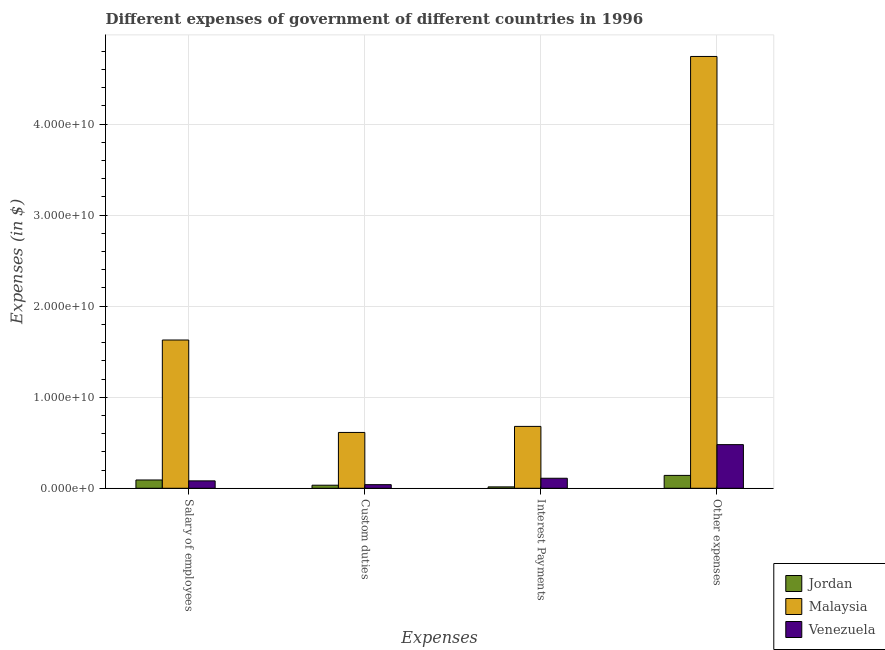How many groups of bars are there?
Offer a very short reply. 4. Are the number of bars on each tick of the X-axis equal?
Your answer should be very brief. Yes. How many bars are there on the 1st tick from the left?
Keep it short and to the point. 3. What is the label of the 3rd group of bars from the left?
Ensure brevity in your answer.  Interest Payments. What is the amount spent on interest payments in Malaysia?
Your answer should be very brief. 6.80e+09. Across all countries, what is the maximum amount spent on interest payments?
Your answer should be very brief. 6.80e+09. Across all countries, what is the minimum amount spent on other expenses?
Provide a succinct answer. 1.41e+09. In which country was the amount spent on interest payments maximum?
Provide a succinct answer. Malaysia. In which country was the amount spent on other expenses minimum?
Your answer should be compact. Jordan. What is the total amount spent on salary of employees in the graph?
Offer a very short reply. 1.80e+1. What is the difference between the amount spent on custom duties in Malaysia and that in Venezuela?
Ensure brevity in your answer.  5.73e+09. What is the difference between the amount spent on salary of employees in Malaysia and the amount spent on other expenses in Jordan?
Make the answer very short. 1.49e+1. What is the average amount spent on salary of employees per country?
Offer a very short reply. 6.00e+09. What is the difference between the amount spent on interest payments and amount spent on custom duties in Venezuela?
Give a very brief answer. 7.02e+08. What is the ratio of the amount spent on custom duties in Malaysia to that in Venezuela?
Make the answer very short. 15.41. Is the amount spent on interest payments in Malaysia less than that in Jordan?
Offer a very short reply. No. Is the difference between the amount spent on salary of employees in Jordan and Malaysia greater than the difference between the amount spent on other expenses in Jordan and Malaysia?
Provide a short and direct response. Yes. What is the difference between the highest and the second highest amount spent on salary of employees?
Keep it short and to the point. 1.54e+1. What is the difference between the highest and the lowest amount spent on interest payments?
Your response must be concise. 6.64e+09. Is the sum of the amount spent on salary of employees in Jordan and Venezuela greater than the maximum amount spent on interest payments across all countries?
Your response must be concise. No. What does the 1st bar from the left in Interest Payments represents?
Provide a short and direct response. Jordan. What does the 2nd bar from the right in Custom duties represents?
Offer a terse response. Malaysia. How many countries are there in the graph?
Give a very brief answer. 3. What is the difference between two consecutive major ticks on the Y-axis?
Provide a succinct answer. 1.00e+1. Are the values on the major ticks of Y-axis written in scientific E-notation?
Offer a very short reply. Yes. Where does the legend appear in the graph?
Offer a very short reply. Bottom right. How many legend labels are there?
Make the answer very short. 3. How are the legend labels stacked?
Provide a short and direct response. Vertical. What is the title of the graph?
Your answer should be compact. Different expenses of government of different countries in 1996. What is the label or title of the X-axis?
Provide a short and direct response. Expenses. What is the label or title of the Y-axis?
Your answer should be very brief. Expenses (in $). What is the Expenses (in $) of Jordan in Salary of employees?
Provide a succinct answer. 9.11e+08. What is the Expenses (in $) in Malaysia in Salary of employees?
Your answer should be very brief. 1.63e+1. What is the Expenses (in $) in Venezuela in Salary of employees?
Offer a very short reply. 8.14e+08. What is the Expenses (in $) in Jordan in Custom duties?
Make the answer very short. 3.36e+08. What is the Expenses (in $) in Malaysia in Custom duties?
Keep it short and to the point. 6.13e+09. What is the Expenses (in $) in Venezuela in Custom duties?
Provide a short and direct response. 3.98e+08. What is the Expenses (in $) of Jordan in Interest Payments?
Provide a short and direct response. 1.53e+08. What is the Expenses (in $) of Malaysia in Interest Payments?
Offer a terse response. 6.80e+09. What is the Expenses (in $) in Venezuela in Interest Payments?
Give a very brief answer. 1.10e+09. What is the Expenses (in $) of Jordan in Other expenses?
Provide a short and direct response. 1.41e+09. What is the Expenses (in $) of Malaysia in Other expenses?
Ensure brevity in your answer.  4.74e+1. What is the Expenses (in $) in Venezuela in Other expenses?
Give a very brief answer. 4.79e+09. Across all Expenses, what is the maximum Expenses (in $) in Jordan?
Provide a succinct answer. 1.41e+09. Across all Expenses, what is the maximum Expenses (in $) in Malaysia?
Make the answer very short. 4.74e+1. Across all Expenses, what is the maximum Expenses (in $) in Venezuela?
Make the answer very short. 4.79e+09. Across all Expenses, what is the minimum Expenses (in $) of Jordan?
Your answer should be compact. 1.53e+08. Across all Expenses, what is the minimum Expenses (in $) of Malaysia?
Give a very brief answer. 6.13e+09. Across all Expenses, what is the minimum Expenses (in $) of Venezuela?
Your response must be concise. 3.98e+08. What is the total Expenses (in $) in Jordan in the graph?
Offer a very short reply. 2.82e+09. What is the total Expenses (in $) of Malaysia in the graph?
Ensure brevity in your answer.  7.66e+1. What is the total Expenses (in $) in Venezuela in the graph?
Your answer should be compact. 7.10e+09. What is the difference between the Expenses (in $) in Jordan in Salary of employees and that in Custom duties?
Your answer should be very brief. 5.75e+08. What is the difference between the Expenses (in $) of Malaysia in Salary of employees and that in Custom duties?
Offer a very short reply. 1.02e+1. What is the difference between the Expenses (in $) in Venezuela in Salary of employees and that in Custom duties?
Give a very brief answer. 4.16e+08. What is the difference between the Expenses (in $) in Jordan in Salary of employees and that in Interest Payments?
Provide a succinct answer. 7.58e+08. What is the difference between the Expenses (in $) in Malaysia in Salary of employees and that in Interest Payments?
Your answer should be very brief. 9.49e+09. What is the difference between the Expenses (in $) in Venezuela in Salary of employees and that in Interest Payments?
Your answer should be compact. -2.86e+08. What is the difference between the Expenses (in $) of Jordan in Salary of employees and that in Other expenses?
Offer a very short reply. -5.04e+08. What is the difference between the Expenses (in $) in Malaysia in Salary of employees and that in Other expenses?
Provide a succinct answer. -3.11e+1. What is the difference between the Expenses (in $) of Venezuela in Salary of employees and that in Other expenses?
Give a very brief answer. -3.98e+09. What is the difference between the Expenses (in $) of Jordan in Custom duties and that in Interest Payments?
Ensure brevity in your answer.  1.83e+08. What is the difference between the Expenses (in $) of Malaysia in Custom duties and that in Interest Payments?
Make the answer very short. -6.63e+08. What is the difference between the Expenses (in $) of Venezuela in Custom duties and that in Interest Payments?
Make the answer very short. -7.02e+08. What is the difference between the Expenses (in $) in Jordan in Custom duties and that in Other expenses?
Your response must be concise. -1.08e+09. What is the difference between the Expenses (in $) in Malaysia in Custom duties and that in Other expenses?
Ensure brevity in your answer.  -4.13e+1. What is the difference between the Expenses (in $) in Venezuela in Custom duties and that in Other expenses?
Make the answer very short. -4.39e+09. What is the difference between the Expenses (in $) in Jordan in Interest Payments and that in Other expenses?
Provide a succinct answer. -1.26e+09. What is the difference between the Expenses (in $) of Malaysia in Interest Payments and that in Other expenses?
Provide a short and direct response. -4.06e+1. What is the difference between the Expenses (in $) in Venezuela in Interest Payments and that in Other expenses?
Your answer should be very brief. -3.69e+09. What is the difference between the Expenses (in $) in Jordan in Salary of employees and the Expenses (in $) in Malaysia in Custom duties?
Offer a terse response. -5.22e+09. What is the difference between the Expenses (in $) in Jordan in Salary of employees and the Expenses (in $) in Venezuela in Custom duties?
Offer a very short reply. 5.13e+08. What is the difference between the Expenses (in $) in Malaysia in Salary of employees and the Expenses (in $) in Venezuela in Custom duties?
Make the answer very short. 1.59e+1. What is the difference between the Expenses (in $) in Jordan in Salary of employees and the Expenses (in $) in Malaysia in Interest Payments?
Keep it short and to the point. -5.88e+09. What is the difference between the Expenses (in $) in Jordan in Salary of employees and the Expenses (in $) in Venezuela in Interest Payments?
Ensure brevity in your answer.  -1.89e+08. What is the difference between the Expenses (in $) in Malaysia in Salary of employees and the Expenses (in $) in Venezuela in Interest Payments?
Your response must be concise. 1.52e+1. What is the difference between the Expenses (in $) of Jordan in Salary of employees and the Expenses (in $) of Malaysia in Other expenses?
Make the answer very short. -4.65e+1. What is the difference between the Expenses (in $) in Jordan in Salary of employees and the Expenses (in $) in Venezuela in Other expenses?
Provide a succinct answer. -3.88e+09. What is the difference between the Expenses (in $) of Malaysia in Salary of employees and the Expenses (in $) of Venezuela in Other expenses?
Offer a very short reply. 1.15e+1. What is the difference between the Expenses (in $) of Jordan in Custom duties and the Expenses (in $) of Malaysia in Interest Payments?
Keep it short and to the point. -6.46e+09. What is the difference between the Expenses (in $) in Jordan in Custom duties and the Expenses (in $) in Venezuela in Interest Payments?
Make the answer very short. -7.64e+08. What is the difference between the Expenses (in $) of Malaysia in Custom duties and the Expenses (in $) of Venezuela in Interest Payments?
Your answer should be very brief. 5.03e+09. What is the difference between the Expenses (in $) in Jordan in Custom duties and the Expenses (in $) in Malaysia in Other expenses?
Make the answer very short. -4.71e+1. What is the difference between the Expenses (in $) of Jordan in Custom duties and the Expenses (in $) of Venezuela in Other expenses?
Offer a very short reply. -4.46e+09. What is the difference between the Expenses (in $) in Malaysia in Custom duties and the Expenses (in $) in Venezuela in Other expenses?
Give a very brief answer. 1.34e+09. What is the difference between the Expenses (in $) in Jordan in Interest Payments and the Expenses (in $) in Malaysia in Other expenses?
Offer a terse response. -4.73e+1. What is the difference between the Expenses (in $) of Jordan in Interest Payments and the Expenses (in $) of Venezuela in Other expenses?
Your answer should be compact. -4.64e+09. What is the difference between the Expenses (in $) in Malaysia in Interest Payments and the Expenses (in $) in Venezuela in Other expenses?
Keep it short and to the point. 2.00e+09. What is the average Expenses (in $) of Jordan per Expenses?
Your answer should be compact. 7.04e+08. What is the average Expenses (in $) of Malaysia per Expenses?
Keep it short and to the point. 1.92e+1. What is the average Expenses (in $) of Venezuela per Expenses?
Provide a short and direct response. 1.78e+09. What is the difference between the Expenses (in $) in Jordan and Expenses (in $) in Malaysia in Salary of employees?
Offer a terse response. -1.54e+1. What is the difference between the Expenses (in $) in Jordan and Expenses (in $) in Venezuela in Salary of employees?
Your answer should be compact. 9.70e+07. What is the difference between the Expenses (in $) in Malaysia and Expenses (in $) in Venezuela in Salary of employees?
Give a very brief answer. 1.55e+1. What is the difference between the Expenses (in $) of Jordan and Expenses (in $) of Malaysia in Custom duties?
Your answer should be compact. -5.80e+09. What is the difference between the Expenses (in $) of Jordan and Expenses (in $) of Venezuela in Custom duties?
Make the answer very short. -6.17e+07. What is the difference between the Expenses (in $) of Malaysia and Expenses (in $) of Venezuela in Custom duties?
Your answer should be very brief. 5.73e+09. What is the difference between the Expenses (in $) of Jordan and Expenses (in $) of Malaysia in Interest Payments?
Provide a succinct answer. -6.64e+09. What is the difference between the Expenses (in $) in Jordan and Expenses (in $) in Venezuela in Interest Payments?
Provide a succinct answer. -9.47e+08. What is the difference between the Expenses (in $) of Malaysia and Expenses (in $) of Venezuela in Interest Payments?
Ensure brevity in your answer.  5.69e+09. What is the difference between the Expenses (in $) in Jordan and Expenses (in $) in Malaysia in Other expenses?
Give a very brief answer. -4.60e+1. What is the difference between the Expenses (in $) in Jordan and Expenses (in $) in Venezuela in Other expenses?
Provide a succinct answer. -3.38e+09. What is the difference between the Expenses (in $) in Malaysia and Expenses (in $) in Venezuela in Other expenses?
Offer a very short reply. 4.26e+1. What is the ratio of the Expenses (in $) of Jordan in Salary of employees to that in Custom duties?
Ensure brevity in your answer.  2.71. What is the ratio of the Expenses (in $) in Malaysia in Salary of employees to that in Custom duties?
Your response must be concise. 2.66. What is the ratio of the Expenses (in $) in Venezuela in Salary of employees to that in Custom duties?
Provide a short and direct response. 2.05. What is the ratio of the Expenses (in $) in Jordan in Salary of employees to that in Interest Payments?
Give a very brief answer. 5.94. What is the ratio of the Expenses (in $) of Malaysia in Salary of employees to that in Interest Payments?
Give a very brief answer. 2.4. What is the ratio of the Expenses (in $) of Venezuela in Salary of employees to that in Interest Payments?
Your response must be concise. 0.74. What is the ratio of the Expenses (in $) in Jordan in Salary of employees to that in Other expenses?
Keep it short and to the point. 0.64. What is the ratio of the Expenses (in $) in Malaysia in Salary of employees to that in Other expenses?
Provide a short and direct response. 0.34. What is the ratio of the Expenses (in $) in Venezuela in Salary of employees to that in Other expenses?
Give a very brief answer. 0.17. What is the ratio of the Expenses (in $) of Jordan in Custom duties to that in Interest Payments?
Offer a very short reply. 2.19. What is the ratio of the Expenses (in $) of Malaysia in Custom duties to that in Interest Payments?
Provide a succinct answer. 0.9. What is the ratio of the Expenses (in $) of Venezuela in Custom duties to that in Interest Payments?
Provide a short and direct response. 0.36. What is the ratio of the Expenses (in $) in Jordan in Custom duties to that in Other expenses?
Your response must be concise. 0.24. What is the ratio of the Expenses (in $) of Malaysia in Custom duties to that in Other expenses?
Give a very brief answer. 0.13. What is the ratio of the Expenses (in $) of Venezuela in Custom duties to that in Other expenses?
Your response must be concise. 0.08. What is the ratio of the Expenses (in $) of Jordan in Interest Payments to that in Other expenses?
Make the answer very short. 0.11. What is the ratio of the Expenses (in $) in Malaysia in Interest Payments to that in Other expenses?
Your answer should be very brief. 0.14. What is the ratio of the Expenses (in $) of Venezuela in Interest Payments to that in Other expenses?
Your answer should be compact. 0.23. What is the difference between the highest and the second highest Expenses (in $) of Jordan?
Provide a short and direct response. 5.04e+08. What is the difference between the highest and the second highest Expenses (in $) of Malaysia?
Your answer should be very brief. 3.11e+1. What is the difference between the highest and the second highest Expenses (in $) of Venezuela?
Make the answer very short. 3.69e+09. What is the difference between the highest and the lowest Expenses (in $) in Jordan?
Your answer should be very brief. 1.26e+09. What is the difference between the highest and the lowest Expenses (in $) of Malaysia?
Give a very brief answer. 4.13e+1. What is the difference between the highest and the lowest Expenses (in $) of Venezuela?
Your response must be concise. 4.39e+09. 